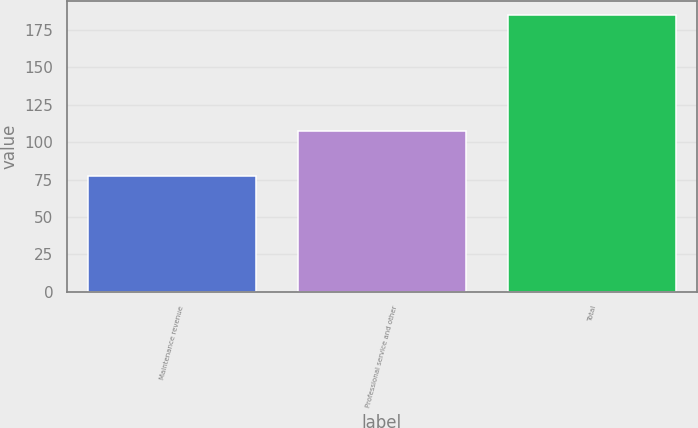<chart> <loc_0><loc_0><loc_500><loc_500><bar_chart><fcel>Maintenance revenue<fcel>Professional service and other<fcel>Total<nl><fcel>77.6<fcel>107.2<fcel>184.8<nl></chart> 